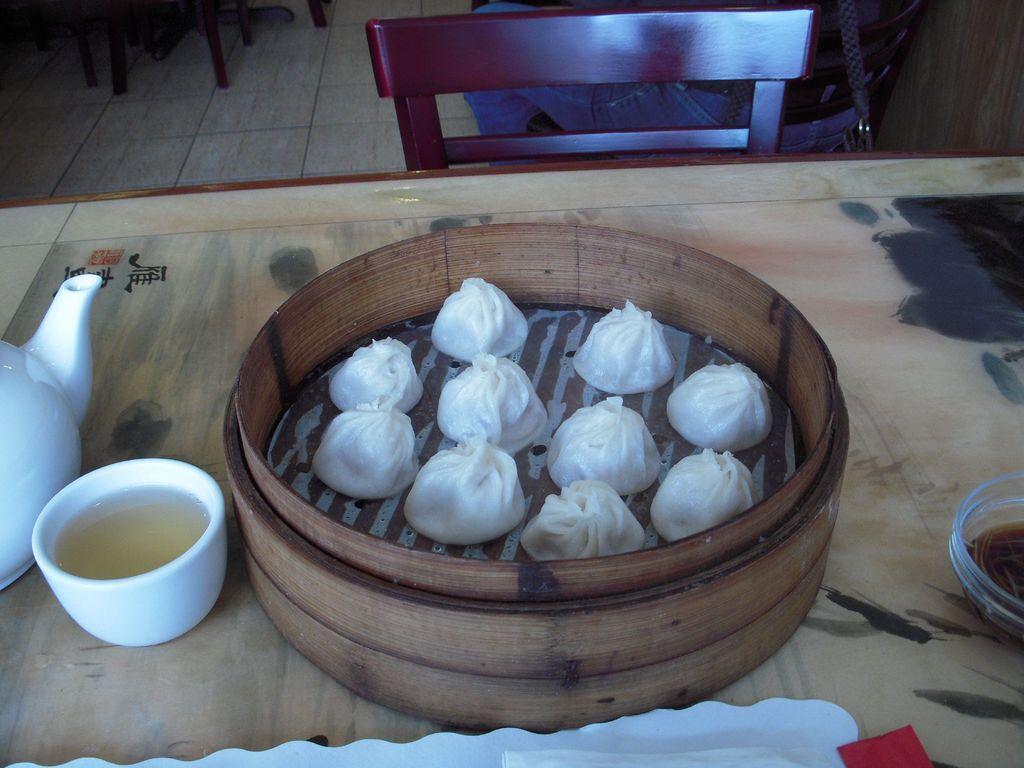In one or two sentences, can you explain what this image depicts? We can see kettle,cup,food,container,bowl on the table. In front of this table there is a person sitting on the chair. We can see chairs on the floor. 